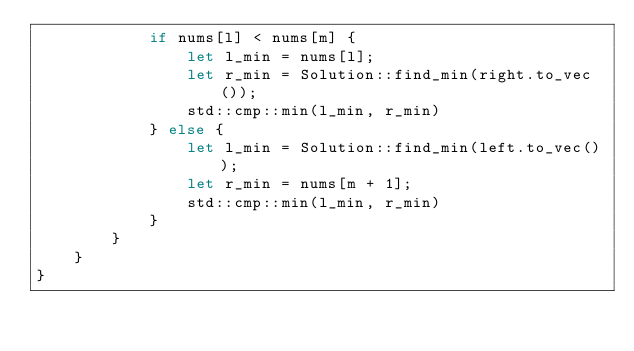<code> <loc_0><loc_0><loc_500><loc_500><_Rust_>            if nums[l] < nums[m] {
                let l_min = nums[l];
                let r_min = Solution::find_min(right.to_vec());
                std::cmp::min(l_min, r_min)
            } else {
                let l_min = Solution::find_min(left.to_vec());
                let r_min = nums[m + 1];
                std::cmp::min(l_min, r_min)
            }
        }
    }
}
</code> 